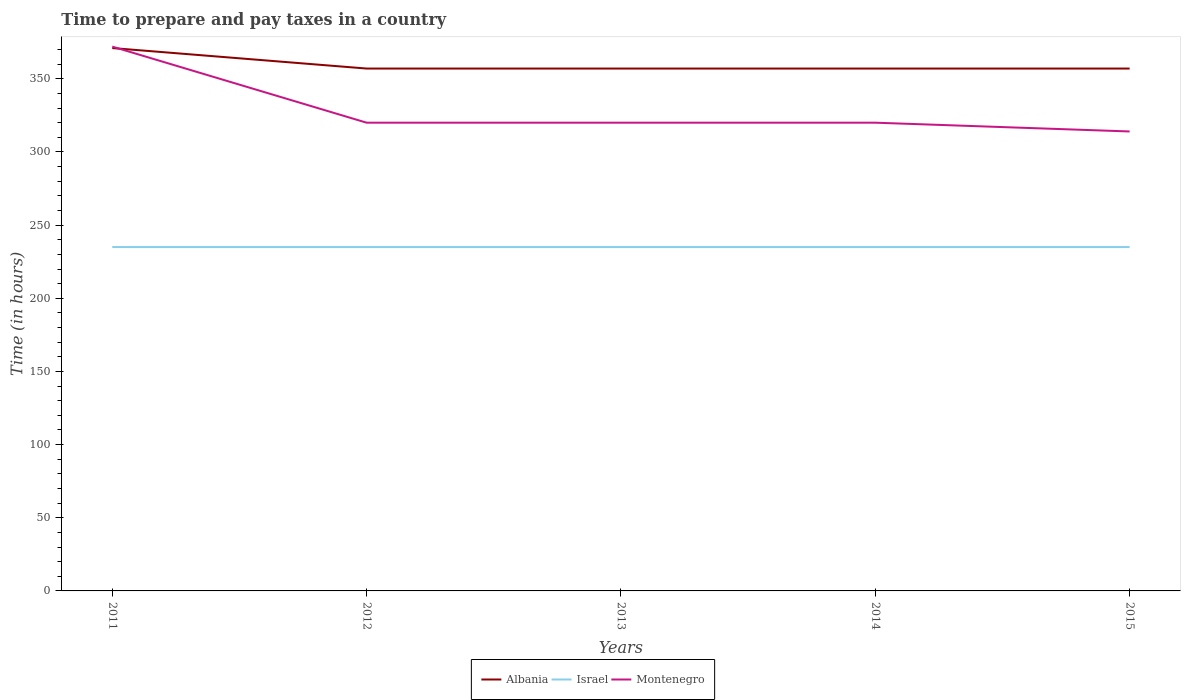How many different coloured lines are there?
Provide a succinct answer. 3. Across all years, what is the maximum number of hours required to prepare and pay taxes in Montenegro?
Provide a succinct answer. 314. In which year was the number of hours required to prepare and pay taxes in Israel maximum?
Your answer should be very brief. 2011. Is the number of hours required to prepare and pay taxes in Israel strictly greater than the number of hours required to prepare and pay taxes in Montenegro over the years?
Give a very brief answer. Yes. How many lines are there?
Provide a short and direct response. 3. What is the title of the graph?
Your answer should be compact. Time to prepare and pay taxes in a country. Does "American Samoa" appear as one of the legend labels in the graph?
Your answer should be compact. No. What is the label or title of the X-axis?
Your response must be concise. Years. What is the label or title of the Y-axis?
Keep it short and to the point. Time (in hours). What is the Time (in hours) in Albania in 2011?
Keep it short and to the point. 371. What is the Time (in hours) of Israel in 2011?
Provide a succinct answer. 235. What is the Time (in hours) of Montenegro in 2011?
Your response must be concise. 372. What is the Time (in hours) in Albania in 2012?
Your answer should be compact. 357. What is the Time (in hours) of Israel in 2012?
Your answer should be very brief. 235. What is the Time (in hours) of Montenegro in 2012?
Make the answer very short. 320. What is the Time (in hours) of Albania in 2013?
Ensure brevity in your answer.  357. What is the Time (in hours) in Israel in 2013?
Offer a terse response. 235. What is the Time (in hours) of Montenegro in 2013?
Provide a short and direct response. 320. What is the Time (in hours) of Albania in 2014?
Your answer should be very brief. 357. What is the Time (in hours) in Israel in 2014?
Make the answer very short. 235. What is the Time (in hours) of Montenegro in 2014?
Keep it short and to the point. 320. What is the Time (in hours) in Albania in 2015?
Your answer should be compact. 357. What is the Time (in hours) of Israel in 2015?
Your response must be concise. 235. What is the Time (in hours) in Montenegro in 2015?
Offer a very short reply. 314. Across all years, what is the maximum Time (in hours) in Albania?
Your response must be concise. 371. Across all years, what is the maximum Time (in hours) in Israel?
Keep it short and to the point. 235. Across all years, what is the maximum Time (in hours) in Montenegro?
Offer a very short reply. 372. Across all years, what is the minimum Time (in hours) in Albania?
Keep it short and to the point. 357. Across all years, what is the minimum Time (in hours) of Israel?
Your answer should be compact. 235. Across all years, what is the minimum Time (in hours) in Montenegro?
Provide a short and direct response. 314. What is the total Time (in hours) of Albania in the graph?
Keep it short and to the point. 1799. What is the total Time (in hours) of Israel in the graph?
Give a very brief answer. 1175. What is the total Time (in hours) of Montenegro in the graph?
Your answer should be compact. 1646. What is the difference between the Time (in hours) in Israel in 2011 and that in 2013?
Offer a very short reply. 0. What is the difference between the Time (in hours) in Montenegro in 2011 and that in 2014?
Keep it short and to the point. 52. What is the difference between the Time (in hours) in Albania in 2011 and that in 2015?
Ensure brevity in your answer.  14. What is the difference between the Time (in hours) of Albania in 2012 and that in 2013?
Provide a short and direct response. 0. What is the difference between the Time (in hours) in Israel in 2012 and that in 2013?
Keep it short and to the point. 0. What is the difference between the Time (in hours) in Montenegro in 2012 and that in 2014?
Keep it short and to the point. 0. What is the difference between the Time (in hours) of Israel in 2012 and that in 2015?
Your answer should be very brief. 0. What is the difference between the Time (in hours) of Montenegro in 2012 and that in 2015?
Offer a terse response. 6. What is the difference between the Time (in hours) of Albania in 2013 and that in 2014?
Your answer should be very brief. 0. What is the difference between the Time (in hours) of Montenegro in 2013 and that in 2014?
Offer a terse response. 0. What is the difference between the Time (in hours) in Albania in 2013 and that in 2015?
Provide a succinct answer. 0. What is the difference between the Time (in hours) in Montenegro in 2013 and that in 2015?
Offer a terse response. 6. What is the difference between the Time (in hours) of Israel in 2014 and that in 2015?
Provide a short and direct response. 0. What is the difference between the Time (in hours) of Montenegro in 2014 and that in 2015?
Your answer should be compact. 6. What is the difference between the Time (in hours) of Albania in 2011 and the Time (in hours) of Israel in 2012?
Your response must be concise. 136. What is the difference between the Time (in hours) of Israel in 2011 and the Time (in hours) of Montenegro in 2012?
Make the answer very short. -85. What is the difference between the Time (in hours) of Albania in 2011 and the Time (in hours) of Israel in 2013?
Your answer should be very brief. 136. What is the difference between the Time (in hours) in Israel in 2011 and the Time (in hours) in Montenegro in 2013?
Make the answer very short. -85. What is the difference between the Time (in hours) of Albania in 2011 and the Time (in hours) of Israel in 2014?
Offer a terse response. 136. What is the difference between the Time (in hours) of Israel in 2011 and the Time (in hours) of Montenegro in 2014?
Make the answer very short. -85. What is the difference between the Time (in hours) in Albania in 2011 and the Time (in hours) in Israel in 2015?
Your answer should be very brief. 136. What is the difference between the Time (in hours) in Albania in 2011 and the Time (in hours) in Montenegro in 2015?
Your response must be concise. 57. What is the difference between the Time (in hours) in Israel in 2011 and the Time (in hours) in Montenegro in 2015?
Your answer should be compact. -79. What is the difference between the Time (in hours) in Albania in 2012 and the Time (in hours) in Israel in 2013?
Keep it short and to the point. 122. What is the difference between the Time (in hours) in Israel in 2012 and the Time (in hours) in Montenegro in 2013?
Offer a terse response. -85. What is the difference between the Time (in hours) in Albania in 2012 and the Time (in hours) in Israel in 2014?
Offer a terse response. 122. What is the difference between the Time (in hours) of Albania in 2012 and the Time (in hours) of Montenegro in 2014?
Give a very brief answer. 37. What is the difference between the Time (in hours) in Israel in 2012 and the Time (in hours) in Montenegro in 2014?
Your answer should be very brief. -85. What is the difference between the Time (in hours) of Albania in 2012 and the Time (in hours) of Israel in 2015?
Keep it short and to the point. 122. What is the difference between the Time (in hours) in Israel in 2012 and the Time (in hours) in Montenegro in 2015?
Provide a short and direct response. -79. What is the difference between the Time (in hours) of Albania in 2013 and the Time (in hours) of Israel in 2014?
Keep it short and to the point. 122. What is the difference between the Time (in hours) of Albania in 2013 and the Time (in hours) of Montenegro in 2014?
Offer a terse response. 37. What is the difference between the Time (in hours) in Israel in 2013 and the Time (in hours) in Montenegro in 2014?
Your answer should be compact. -85. What is the difference between the Time (in hours) in Albania in 2013 and the Time (in hours) in Israel in 2015?
Your answer should be compact. 122. What is the difference between the Time (in hours) of Israel in 2013 and the Time (in hours) of Montenegro in 2015?
Provide a short and direct response. -79. What is the difference between the Time (in hours) in Albania in 2014 and the Time (in hours) in Israel in 2015?
Your answer should be very brief. 122. What is the difference between the Time (in hours) in Albania in 2014 and the Time (in hours) in Montenegro in 2015?
Give a very brief answer. 43. What is the difference between the Time (in hours) of Israel in 2014 and the Time (in hours) of Montenegro in 2015?
Your answer should be very brief. -79. What is the average Time (in hours) in Albania per year?
Ensure brevity in your answer.  359.8. What is the average Time (in hours) in Israel per year?
Your response must be concise. 235. What is the average Time (in hours) of Montenegro per year?
Provide a short and direct response. 329.2. In the year 2011, what is the difference between the Time (in hours) in Albania and Time (in hours) in Israel?
Keep it short and to the point. 136. In the year 2011, what is the difference between the Time (in hours) in Albania and Time (in hours) in Montenegro?
Make the answer very short. -1. In the year 2011, what is the difference between the Time (in hours) of Israel and Time (in hours) of Montenegro?
Make the answer very short. -137. In the year 2012, what is the difference between the Time (in hours) in Albania and Time (in hours) in Israel?
Your answer should be compact. 122. In the year 2012, what is the difference between the Time (in hours) of Israel and Time (in hours) of Montenegro?
Provide a short and direct response. -85. In the year 2013, what is the difference between the Time (in hours) in Albania and Time (in hours) in Israel?
Ensure brevity in your answer.  122. In the year 2013, what is the difference between the Time (in hours) of Albania and Time (in hours) of Montenegro?
Offer a very short reply. 37. In the year 2013, what is the difference between the Time (in hours) of Israel and Time (in hours) of Montenegro?
Ensure brevity in your answer.  -85. In the year 2014, what is the difference between the Time (in hours) in Albania and Time (in hours) in Israel?
Offer a terse response. 122. In the year 2014, what is the difference between the Time (in hours) of Albania and Time (in hours) of Montenegro?
Ensure brevity in your answer.  37. In the year 2014, what is the difference between the Time (in hours) in Israel and Time (in hours) in Montenegro?
Give a very brief answer. -85. In the year 2015, what is the difference between the Time (in hours) of Albania and Time (in hours) of Israel?
Keep it short and to the point. 122. In the year 2015, what is the difference between the Time (in hours) in Israel and Time (in hours) in Montenegro?
Give a very brief answer. -79. What is the ratio of the Time (in hours) in Albania in 2011 to that in 2012?
Offer a very short reply. 1.04. What is the ratio of the Time (in hours) in Israel in 2011 to that in 2012?
Your answer should be compact. 1. What is the ratio of the Time (in hours) in Montenegro in 2011 to that in 2012?
Provide a succinct answer. 1.16. What is the ratio of the Time (in hours) of Albania in 2011 to that in 2013?
Offer a very short reply. 1.04. What is the ratio of the Time (in hours) in Israel in 2011 to that in 2013?
Provide a succinct answer. 1. What is the ratio of the Time (in hours) of Montenegro in 2011 to that in 2013?
Provide a succinct answer. 1.16. What is the ratio of the Time (in hours) in Albania in 2011 to that in 2014?
Provide a short and direct response. 1.04. What is the ratio of the Time (in hours) of Montenegro in 2011 to that in 2014?
Your answer should be very brief. 1.16. What is the ratio of the Time (in hours) of Albania in 2011 to that in 2015?
Offer a very short reply. 1.04. What is the ratio of the Time (in hours) in Montenegro in 2011 to that in 2015?
Your answer should be very brief. 1.18. What is the ratio of the Time (in hours) of Albania in 2012 to that in 2013?
Ensure brevity in your answer.  1. What is the ratio of the Time (in hours) in Israel in 2012 to that in 2013?
Offer a terse response. 1. What is the ratio of the Time (in hours) in Montenegro in 2012 to that in 2015?
Provide a succinct answer. 1.02. What is the ratio of the Time (in hours) in Israel in 2013 to that in 2014?
Your answer should be very brief. 1. What is the ratio of the Time (in hours) in Montenegro in 2013 to that in 2014?
Provide a short and direct response. 1. What is the ratio of the Time (in hours) in Montenegro in 2013 to that in 2015?
Your response must be concise. 1.02. What is the ratio of the Time (in hours) in Montenegro in 2014 to that in 2015?
Keep it short and to the point. 1.02. What is the difference between the highest and the second highest Time (in hours) in Albania?
Provide a short and direct response. 14. What is the difference between the highest and the second highest Time (in hours) in Montenegro?
Offer a terse response. 52. What is the difference between the highest and the lowest Time (in hours) in Albania?
Give a very brief answer. 14. What is the difference between the highest and the lowest Time (in hours) of Montenegro?
Make the answer very short. 58. 